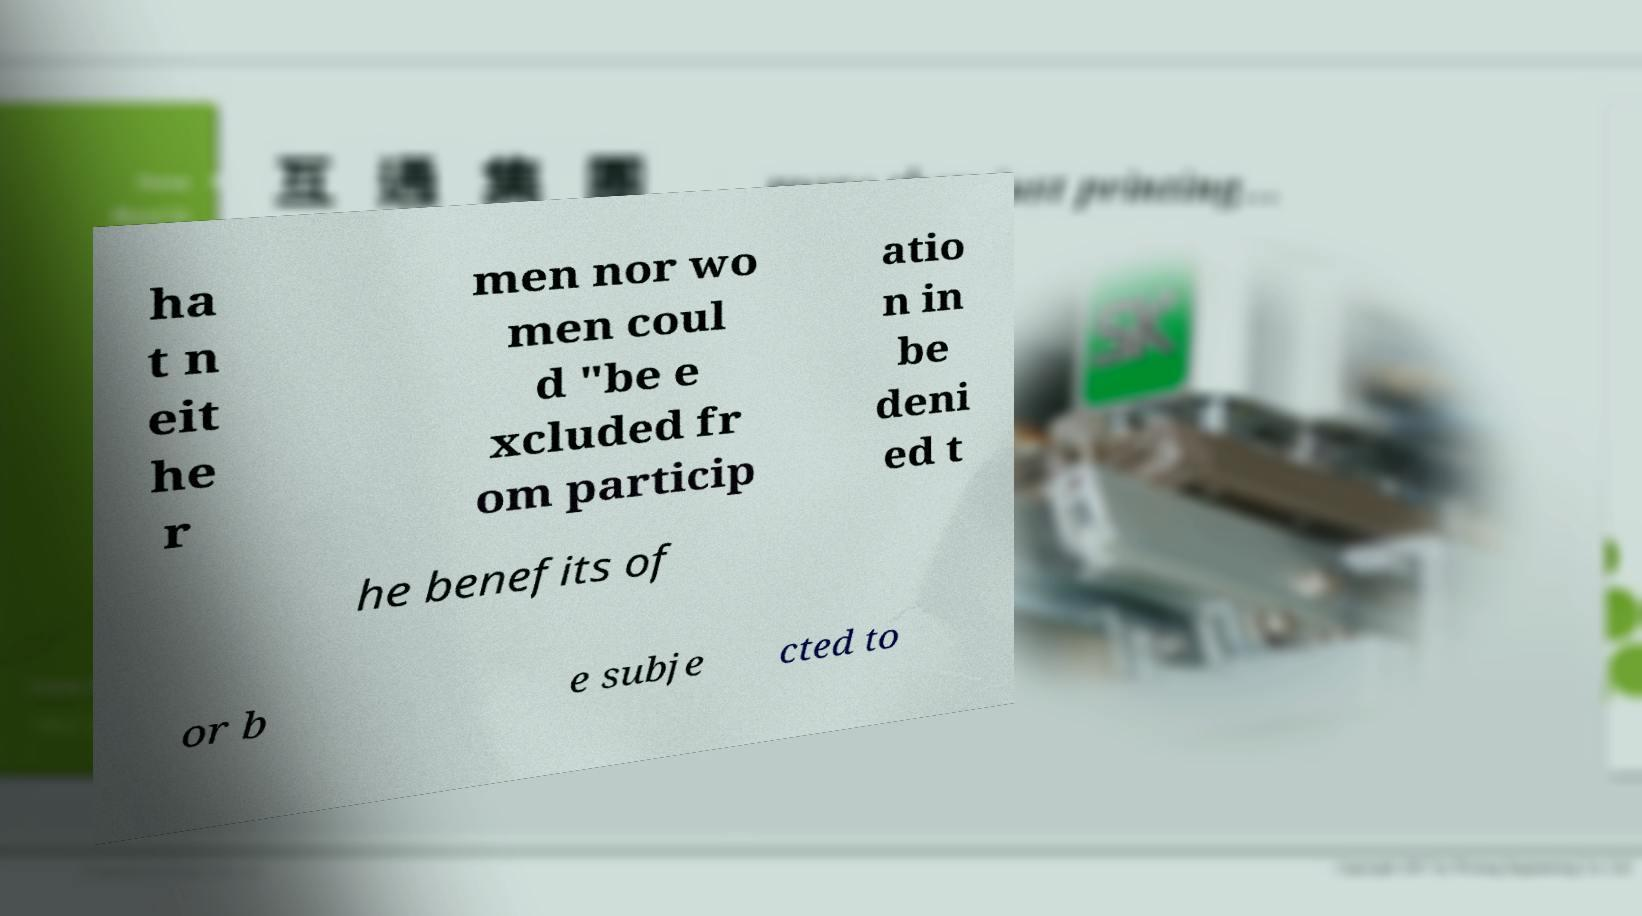Please read and relay the text visible in this image. What does it say? ha t n eit he r men nor wo men coul d "be e xcluded fr om particip atio n in be deni ed t he benefits of or b e subje cted to 